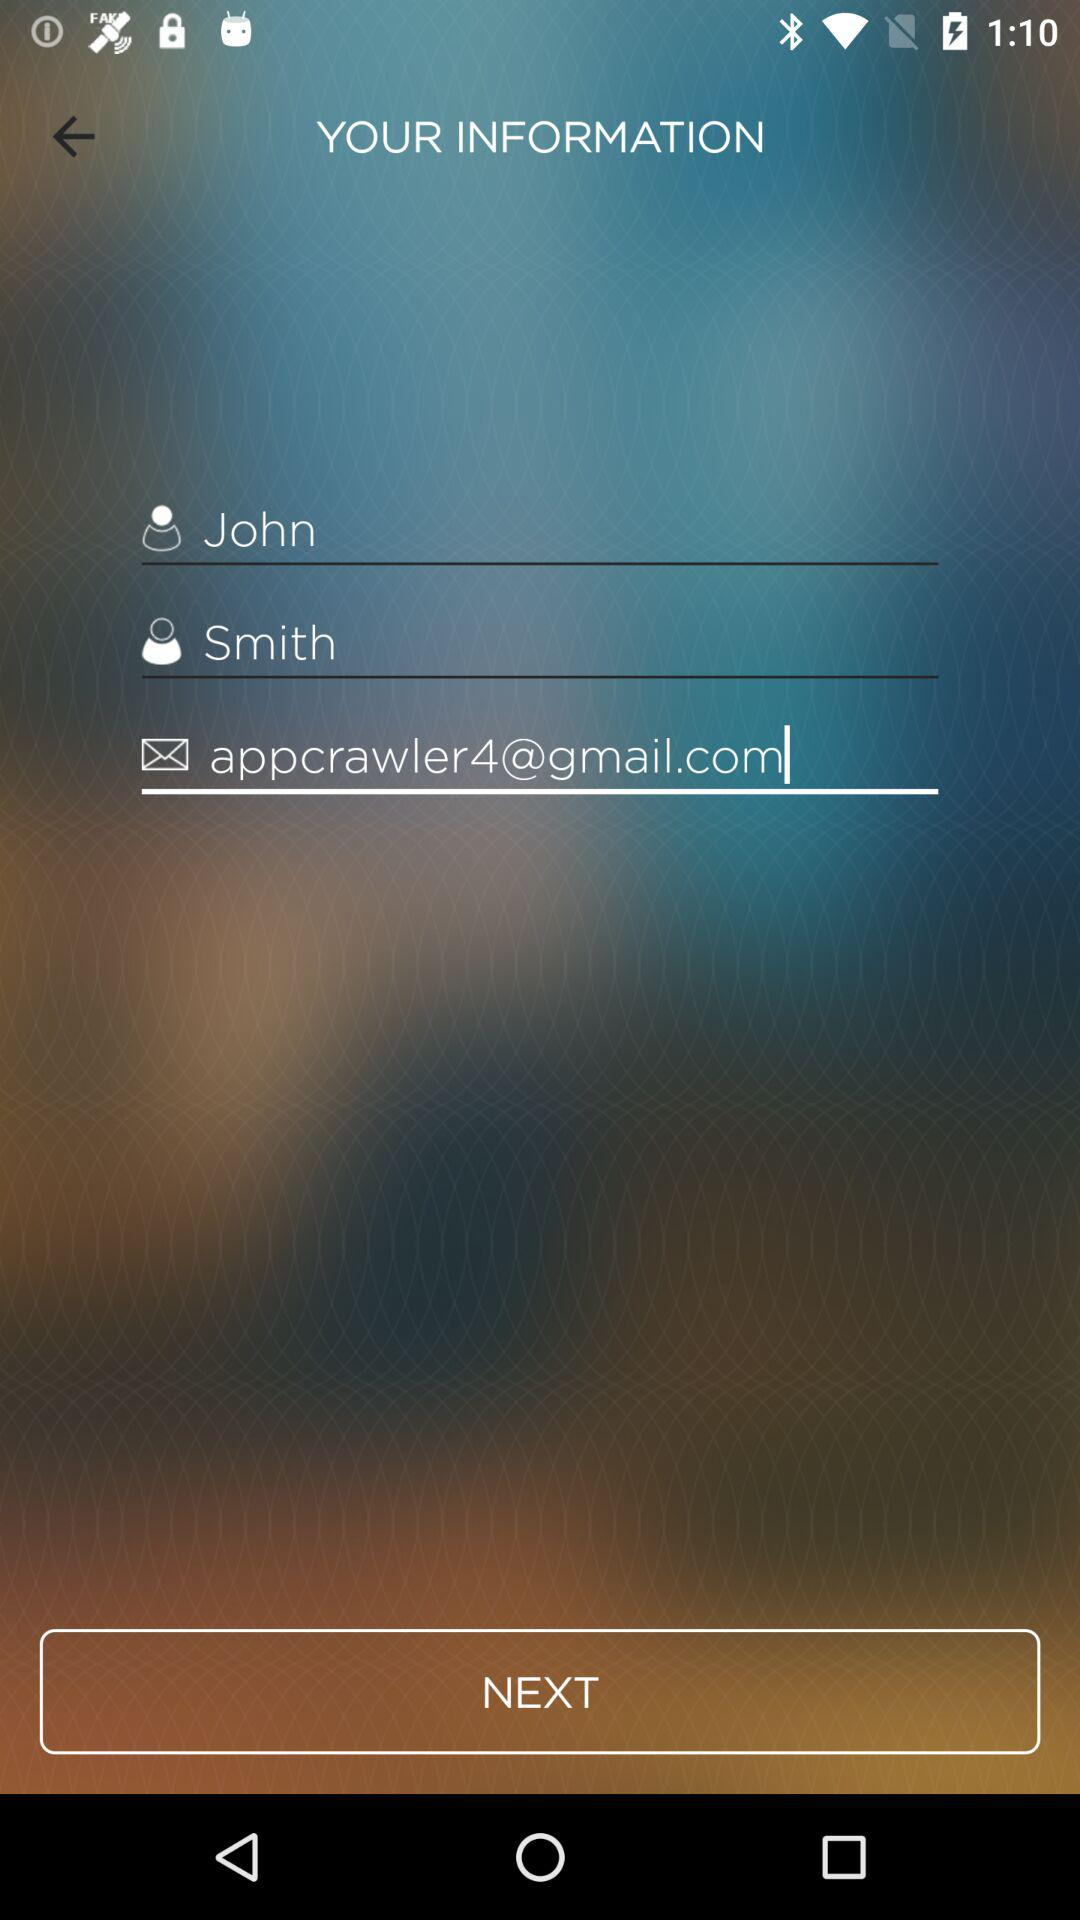What is the email address? The email address is appcrawler4@gmail.com. 